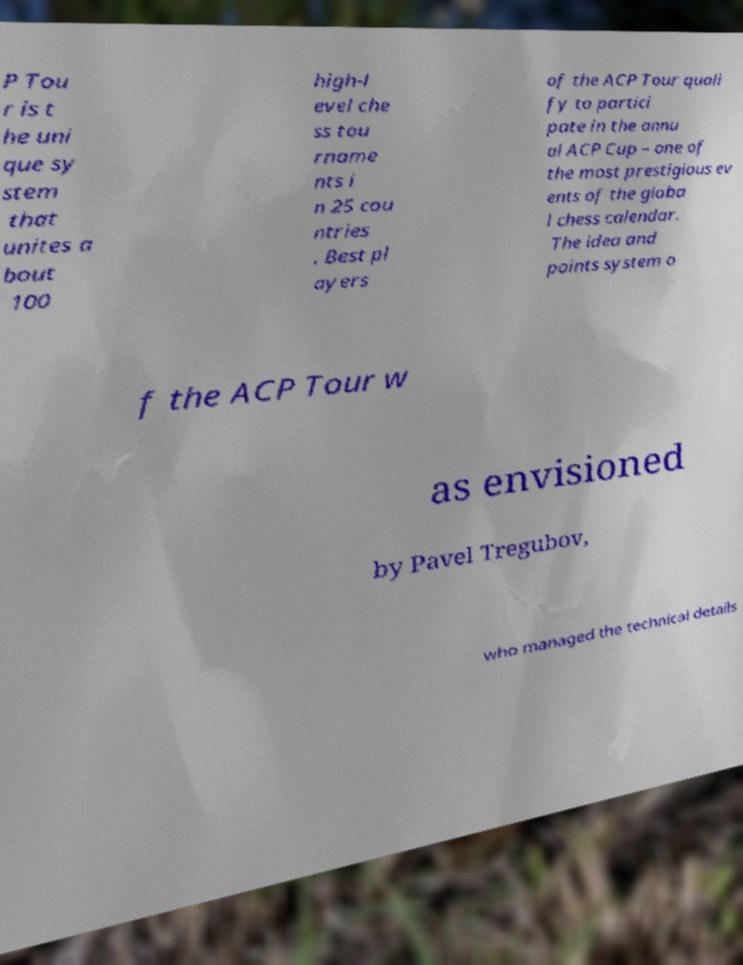Please read and relay the text visible in this image. What does it say? P Tou r is t he uni que sy stem that unites a bout 100 high-l evel che ss tou rname nts i n 25 cou ntries . Best pl ayers of the ACP Tour quali fy to partici pate in the annu al ACP Cup – one of the most prestigious ev ents of the globa l chess calendar. The idea and points system o f the ACP Tour w as envisioned by Pavel Tregubov, who managed the technical details 